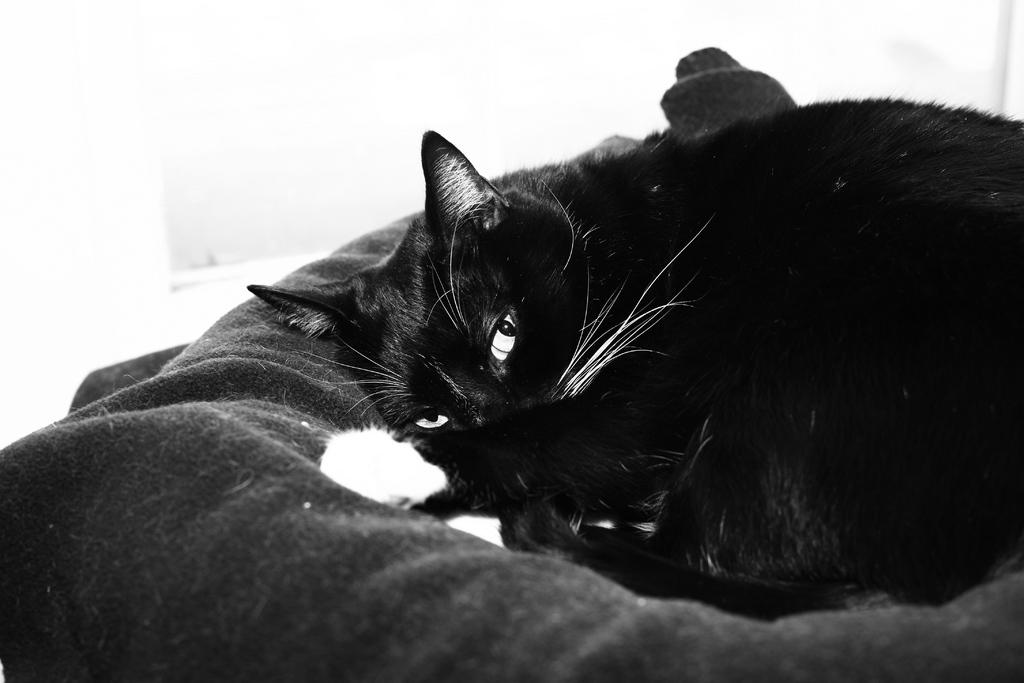What type of creature is present in the image? There is an animal in the image. What is the animal resting on? The animal is on a cloth. What color scheme is used in the image? The image is black and white. What type of guitar is being played by the animal in the image? There is no guitar present in the image; it only features an animal on a cloth. How does the wrist of the animal look in the image? There is no wrist visible in the image, as it only features an animal on a cloth. 